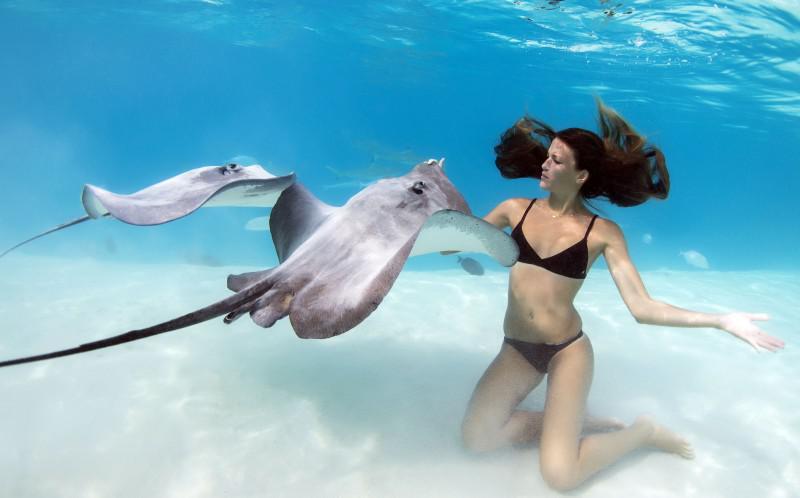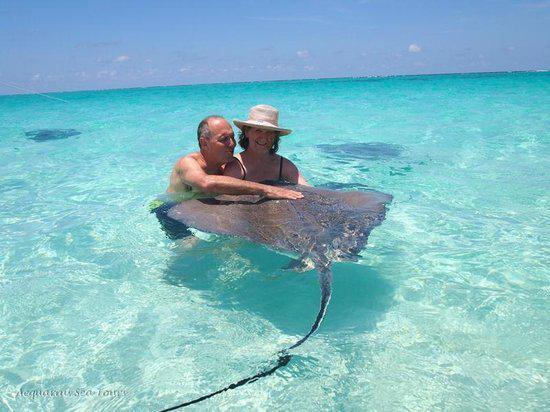The first image is the image on the left, the second image is the image on the right. For the images shown, is this caption "In the left photo, there is a woman kneeling on the ocean floor touching a manta ray." true? Answer yes or no. Yes. 